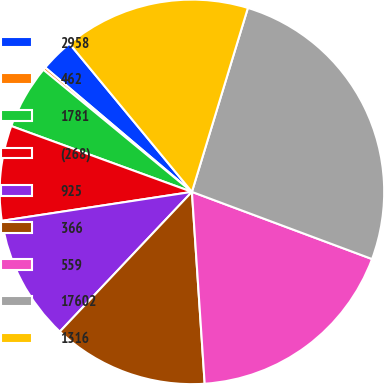Convert chart. <chart><loc_0><loc_0><loc_500><loc_500><pie_chart><fcel>2958<fcel>462<fcel>1781<fcel>(268)<fcel>925<fcel>366<fcel>559<fcel>17602<fcel>1316<nl><fcel>2.82%<fcel>0.24%<fcel>5.39%<fcel>7.97%<fcel>10.54%<fcel>13.11%<fcel>18.26%<fcel>25.98%<fcel>15.69%<nl></chart> 